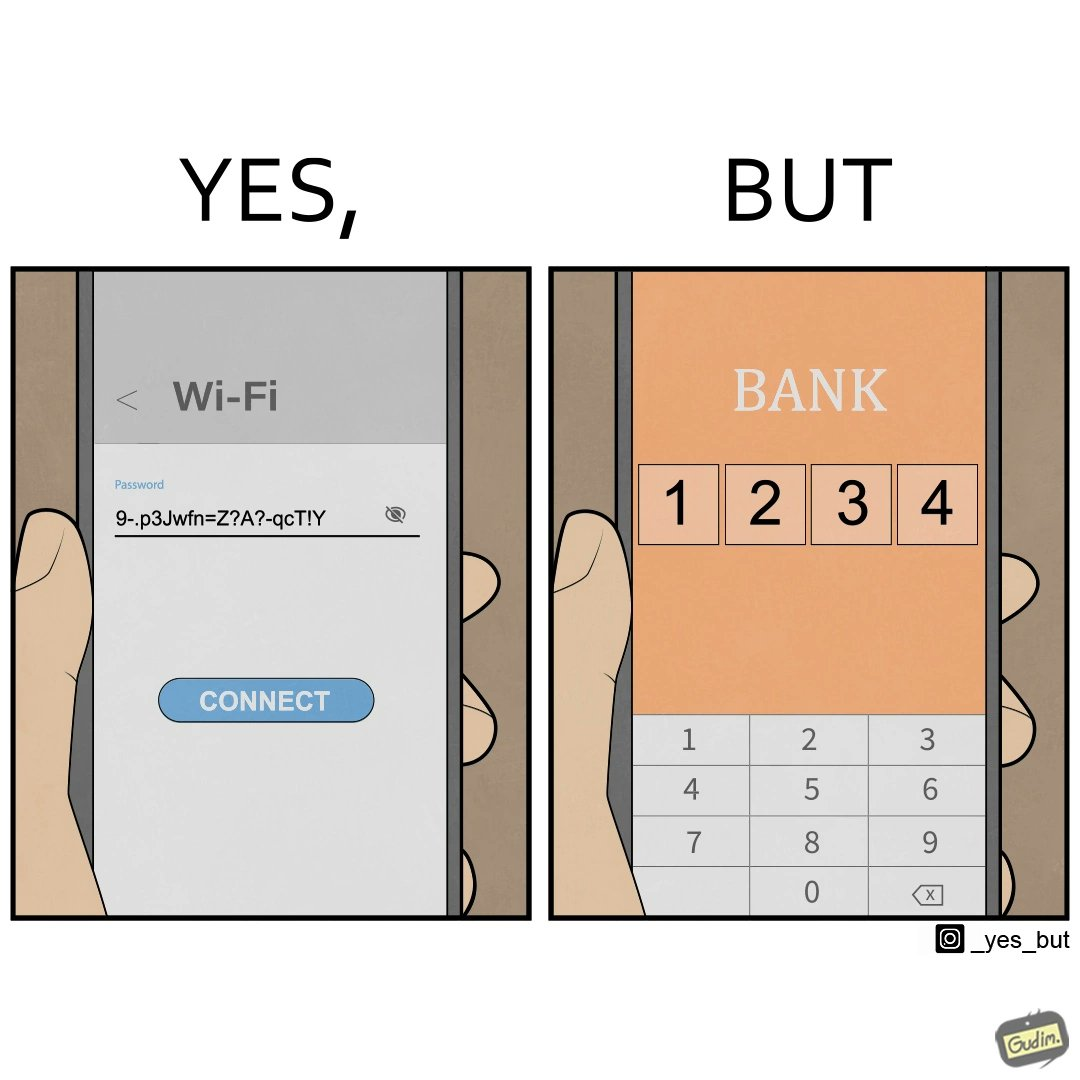Does this image contain satire or humor? Yes, this image is satirical. 